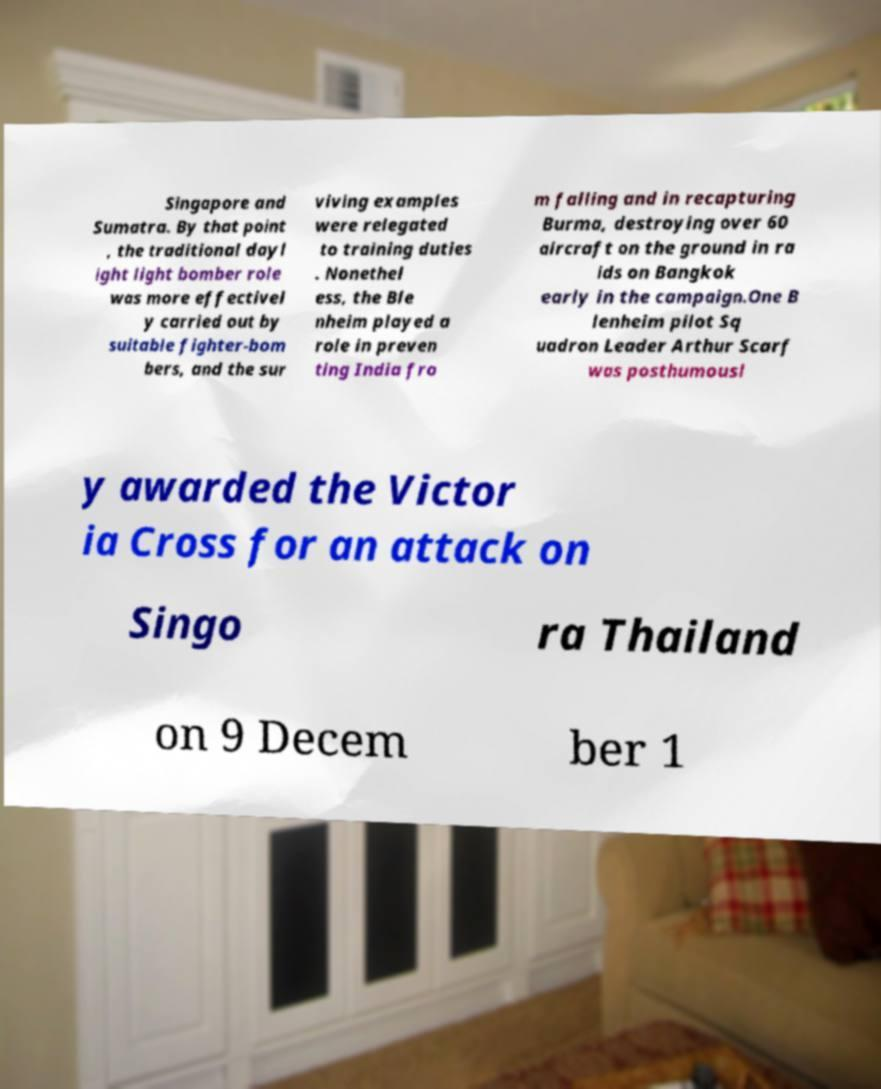Can you read and provide the text displayed in the image?This photo seems to have some interesting text. Can you extract and type it out for me? Singapore and Sumatra. By that point , the traditional dayl ight light bomber role was more effectivel y carried out by suitable fighter-bom bers, and the sur viving examples were relegated to training duties . Nonethel ess, the Ble nheim played a role in preven ting India fro m falling and in recapturing Burma, destroying over 60 aircraft on the ground in ra ids on Bangkok early in the campaign.One B lenheim pilot Sq uadron Leader Arthur Scarf was posthumousl y awarded the Victor ia Cross for an attack on Singo ra Thailand on 9 Decem ber 1 